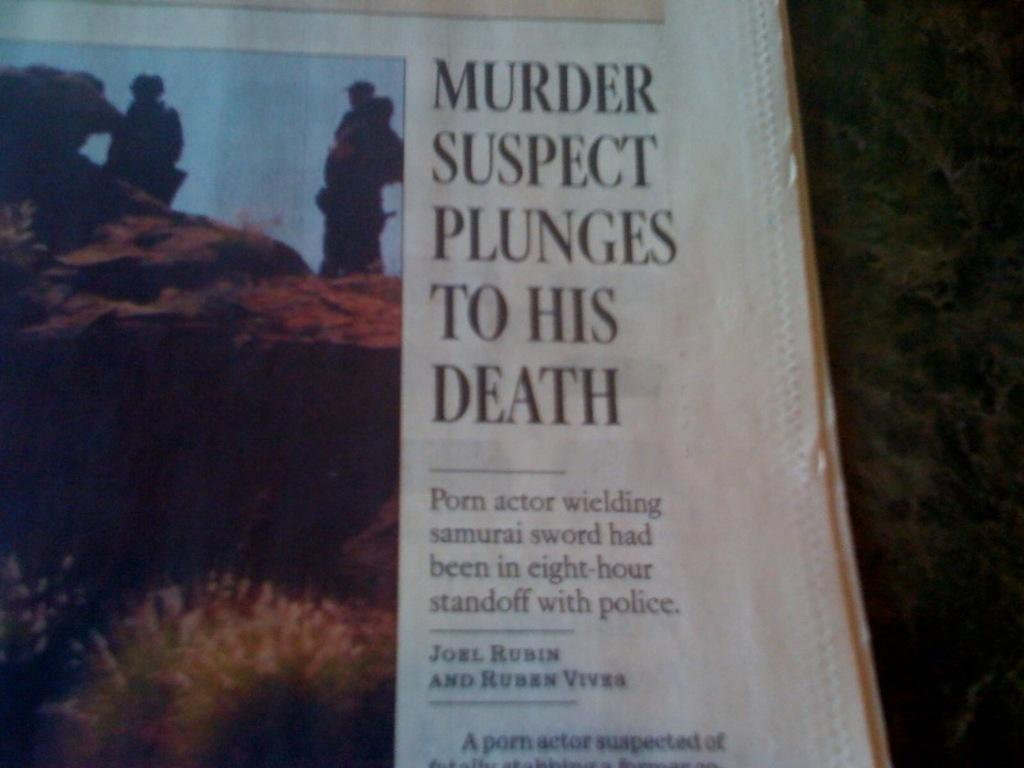<image>
Share a concise interpretation of the image provided. An article in the newspaper talks about a person who was suspected of murder fell to his death. 